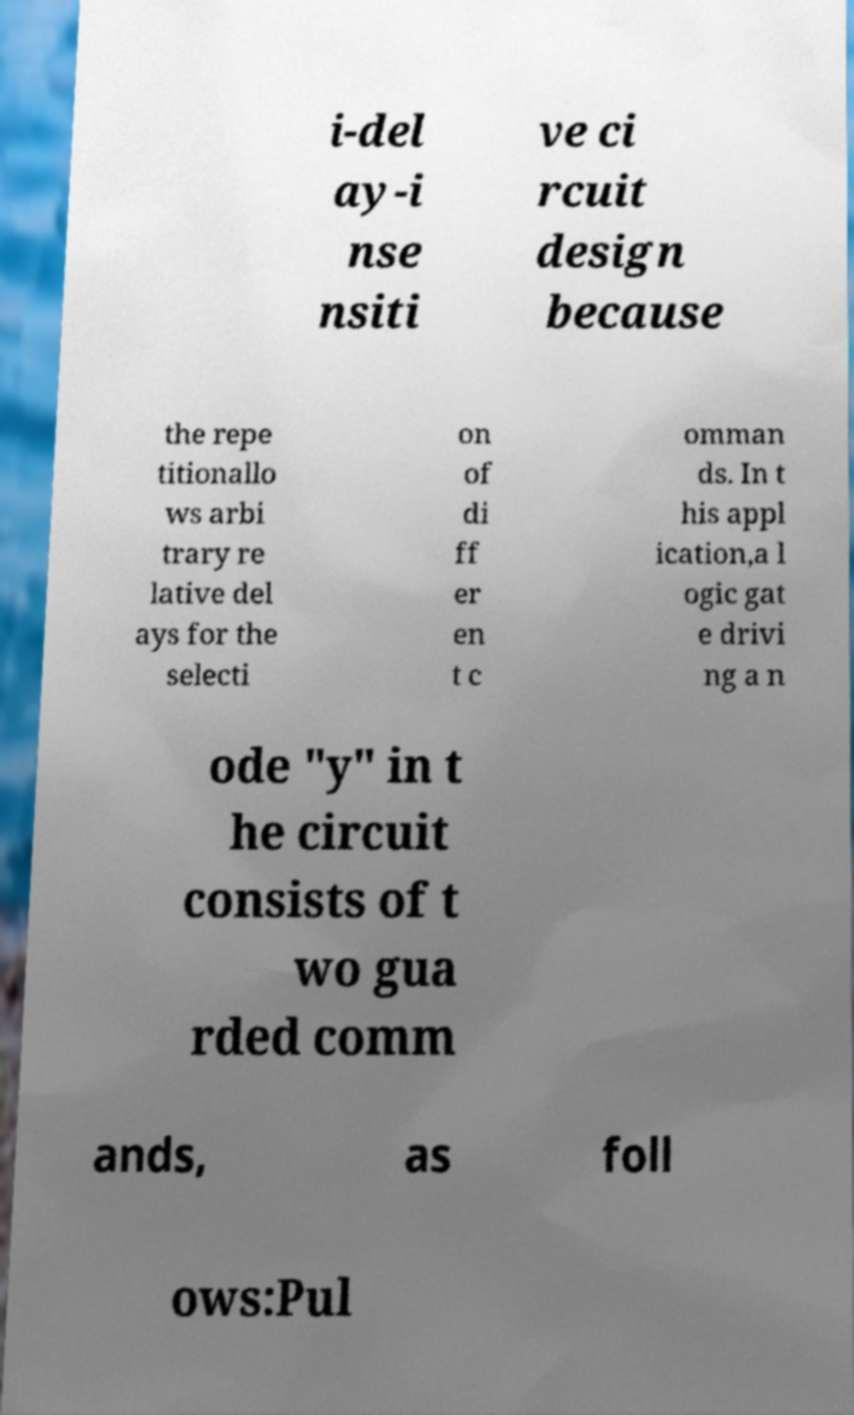Could you extract and type out the text from this image? i-del ay-i nse nsiti ve ci rcuit design because the repe titionallo ws arbi trary re lative del ays for the selecti on of di ff er en t c omman ds. In t his appl ication,a l ogic gat e drivi ng a n ode "y" in t he circuit consists of t wo gua rded comm ands, as foll ows:Pul 